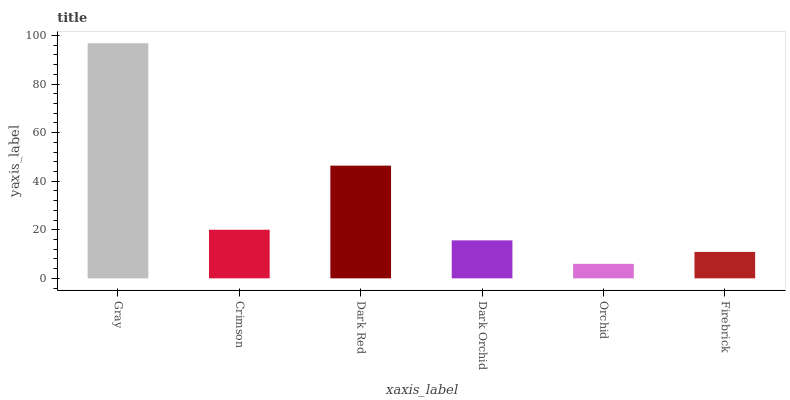Is Crimson the minimum?
Answer yes or no. No. Is Crimson the maximum?
Answer yes or no. No. Is Gray greater than Crimson?
Answer yes or no. Yes. Is Crimson less than Gray?
Answer yes or no. Yes. Is Crimson greater than Gray?
Answer yes or no. No. Is Gray less than Crimson?
Answer yes or no. No. Is Crimson the high median?
Answer yes or no. Yes. Is Dark Orchid the low median?
Answer yes or no. Yes. Is Orchid the high median?
Answer yes or no. No. Is Dark Red the low median?
Answer yes or no. No. 